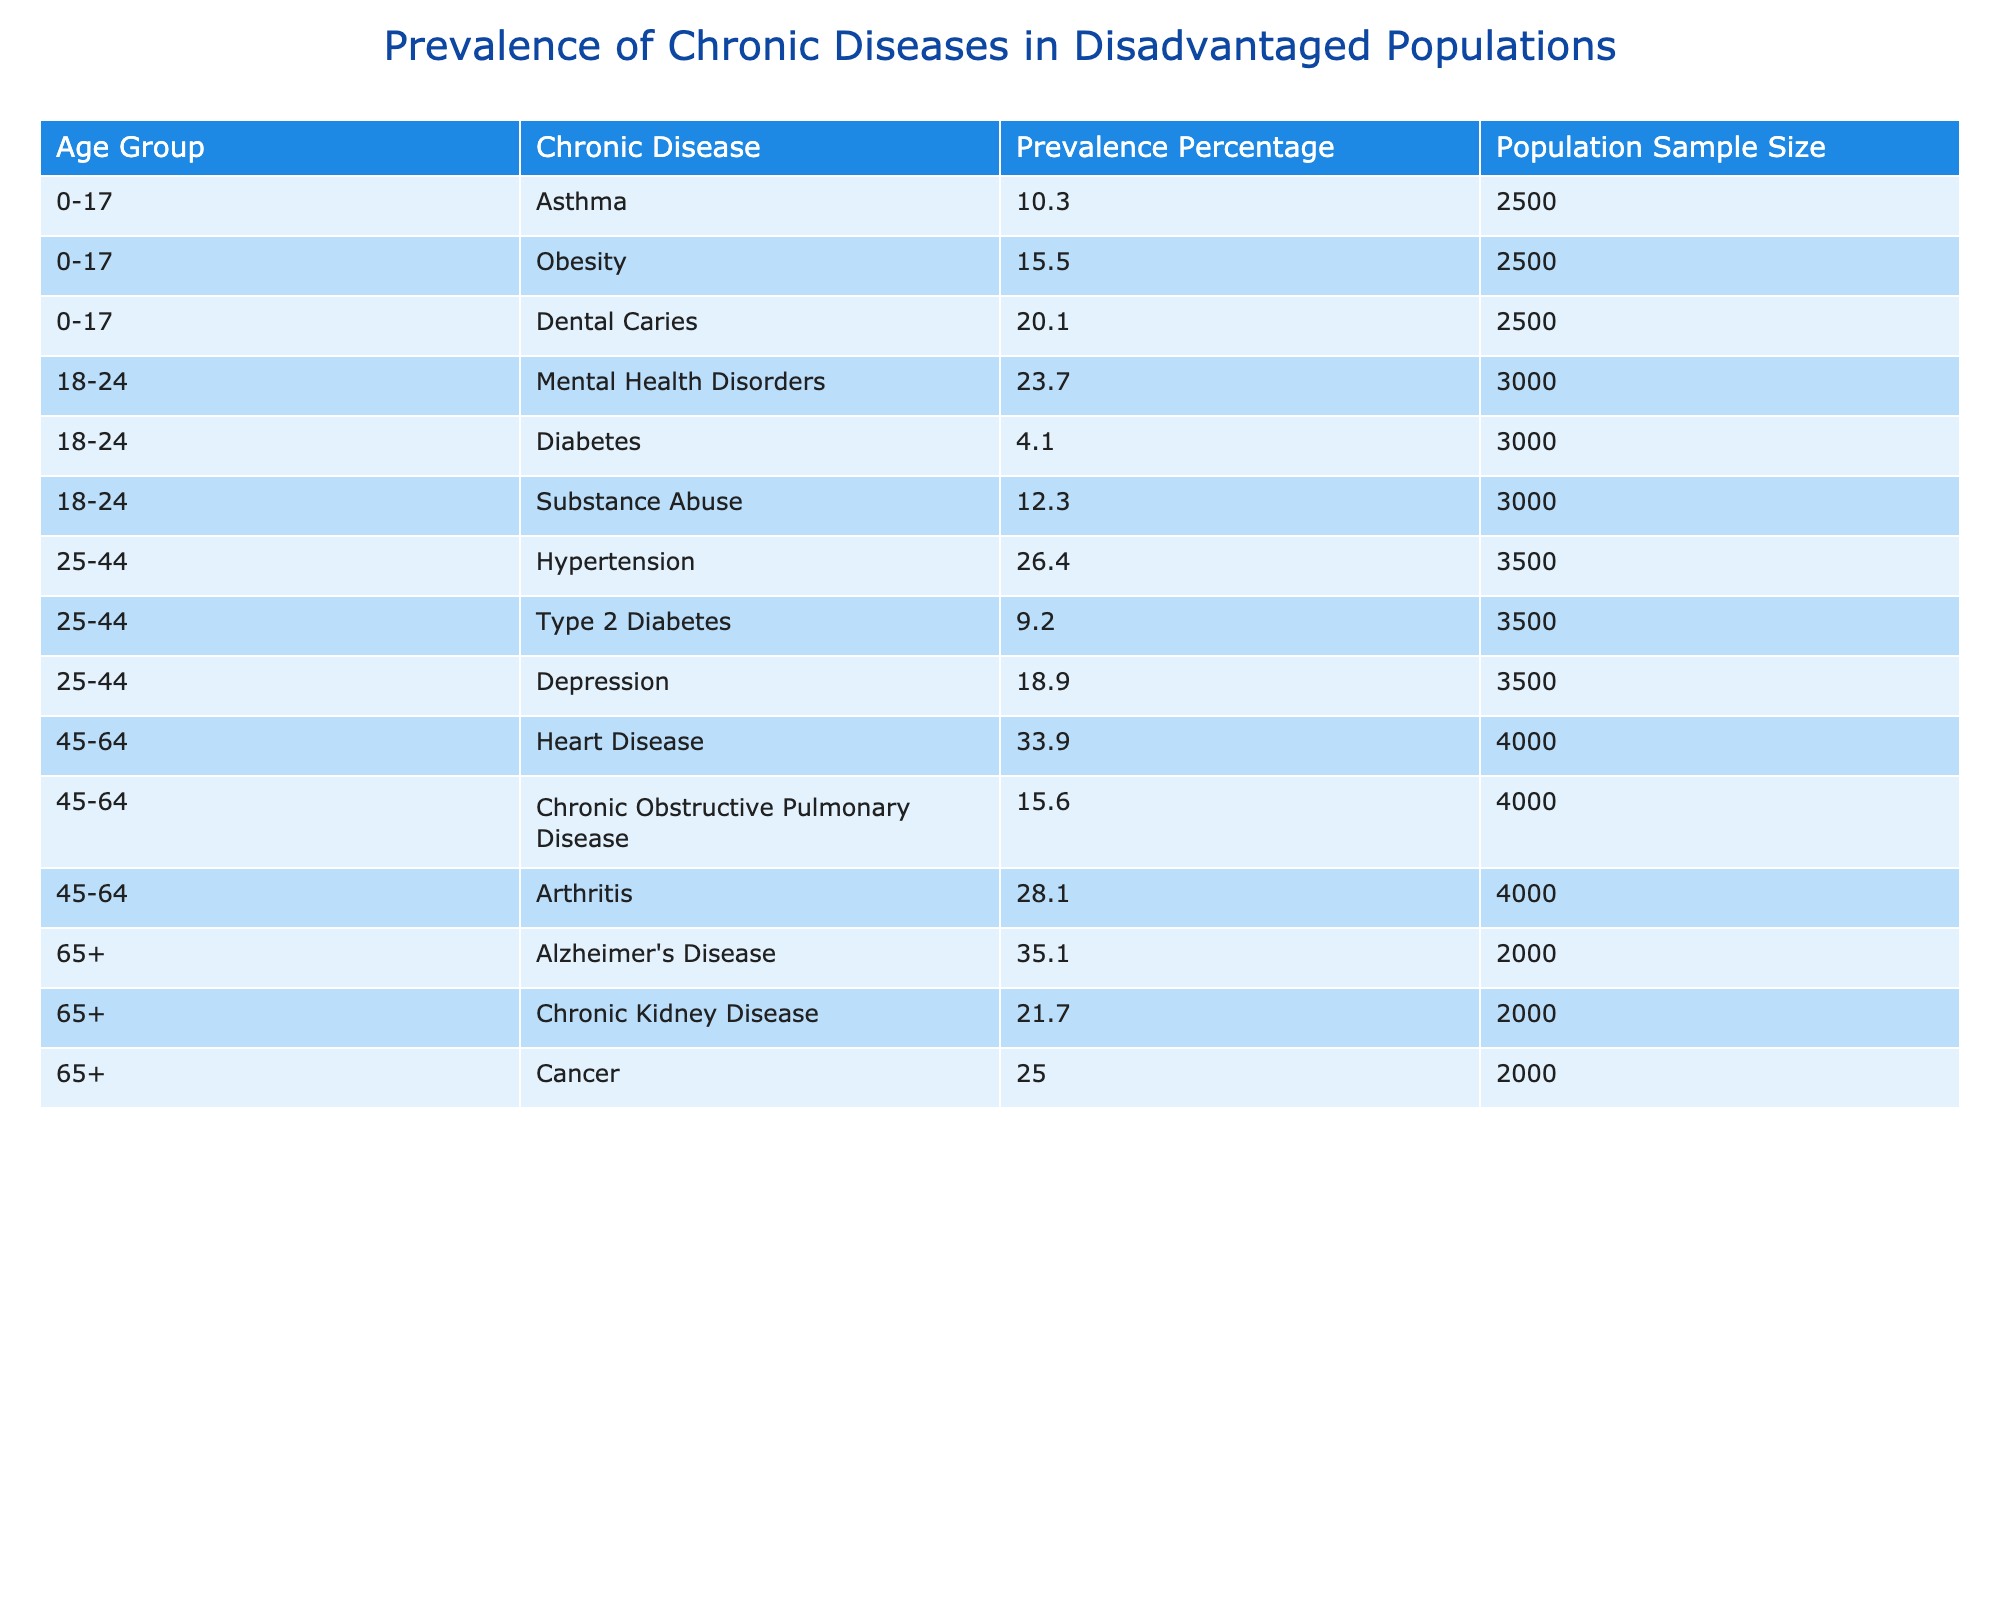What is the prevalence percentage of obesity in the 0-17 age group? The table lists obesity in the 0-17 age group with a prevalence percentage of 15.5.
Answer: 15.5 Which chronic disease has the highest prevalence in the 45-64 age group? In the 45-64 age group, heart disease has the highest prevalence percentage at 33.9, compared to 15.6 for Chronic Obstructive Pulmonary Disease and 28.1 for Arthritis.
Answer: Heart Disease What is the total prevalence percentage for chronic health issues for the 18-24 age group? The chronic health issues for the 18-24 age group are Mental Health Disorders (23.7), Diabetes (4.1), and Substance Abuse (12.3). Adding these percentages gives 23.7 + 4.1 + 12.3 = 40.1.
Answer: 40.1 Is the prevalence of Alzheimer's Disease greater than that of Chronic Kidney Disease in the 65+ age group? The prevalence of Alzheimer's Disease is 35.1, while that of Chronic Kidney Disease is 21.7. Since 35.1 is greater than 21.7, the statement is true.
Answer: Yes What is the average prevalence percentage of chronic diseases among the 25-44 age group? The chronic diseases in the 25-44 age group are Hypertension (26.4), Type 2 Diabetes (9.2), and Depression (18.9). The total is 26.4 + 9.2 + 18.9 = 54.5, and dividing by 3 gives an average of 54.5/3 = 18.17.
Answer: 18.17 Which age group shows a higher prevalence of chronic diseases on average, 0-17 or 45-64? The average prevalence for 0-17 is (10.3 + 15.5 + 20.1)/3 = 15.30, and for 45-64 it is (33.9 + 15.6 + 28.1)/3 = 25.8. Since 25.8 > 15.30, 45-64 has a higher average.
Answer: 45-64 Is the population sample size for the 25-44 age group larger than for the 0-17 age group? The population sample size for the 25-44 age group is 3500, while for the 0-17 age group it is 2500. Since 3500 is greater than 2500, the statement is true.
Answer: Yes What is the difference in prevalence percentage between the Heart Disease and Depression in the 25-44 age group? Heart Disease has a prevalence of 33.9 and Depression has a prevalence of 18.9. The difference is 33.9 - 18.9 = 15.0.
Answer: 15.0 In what age group is the prevalence of obesity highest compared to other chronic diseases? In the 0-17 age group, obesity has a prevalence of 15.5, which is higher than Asthma (10.3) and Dental Caries (20.1), as Dental Caries has the highest in this age group, so it is not the highest among all chronic diseases across all age groups. By observation from the table, obesity is not the highest compared to others.
Answer: No 